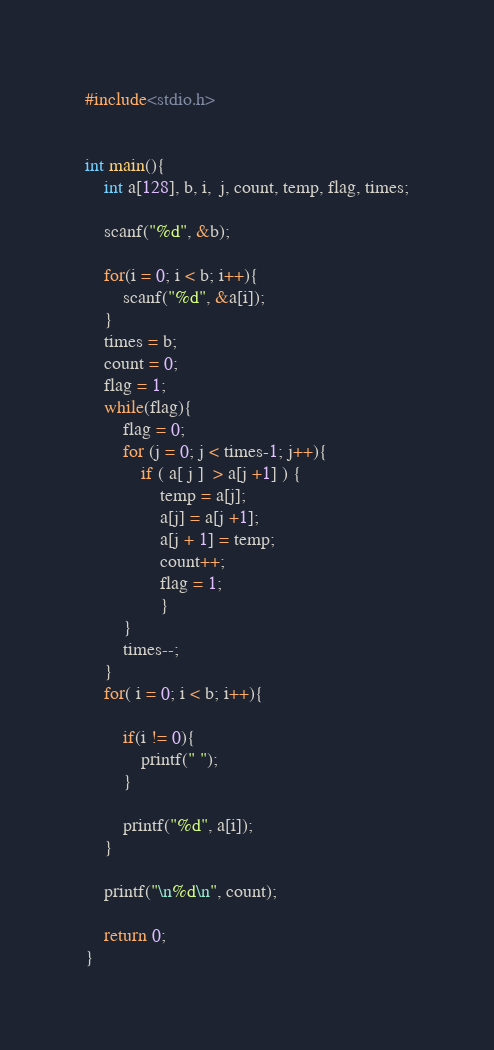<code> <loc_0><loc_0><loc_500><loc_500><_C_>#include<stdio.h>


int main(){
    int a[128], b, i,  j, count, temp, flag, times;
    
    scanf("%d", &b);
    
    for(i = 0; i < b; i++){
        scanf("%d", &a[i]);
    }
    times = b;
    count = 0;
    flag = 1;    
    while(flag){
        flag = 0;
        for (j = 0; j < times-1; j++){
            if ( a[ j ]  > a[j +1] ) {
                temp = a[j];
                a[j] = a[j +1];
                a[j + 1] = temp;
                count++;
                flag = 1;
                } 
        }
        times--;
    }
    for( i = 0; i < b; i++){
        
        if(i != 0){
            printf(" ");
        }
        
        printf("%d", a[i]);
    }
        
    printf("\n%d\n", count);
    
    return 0;
}

</code> 